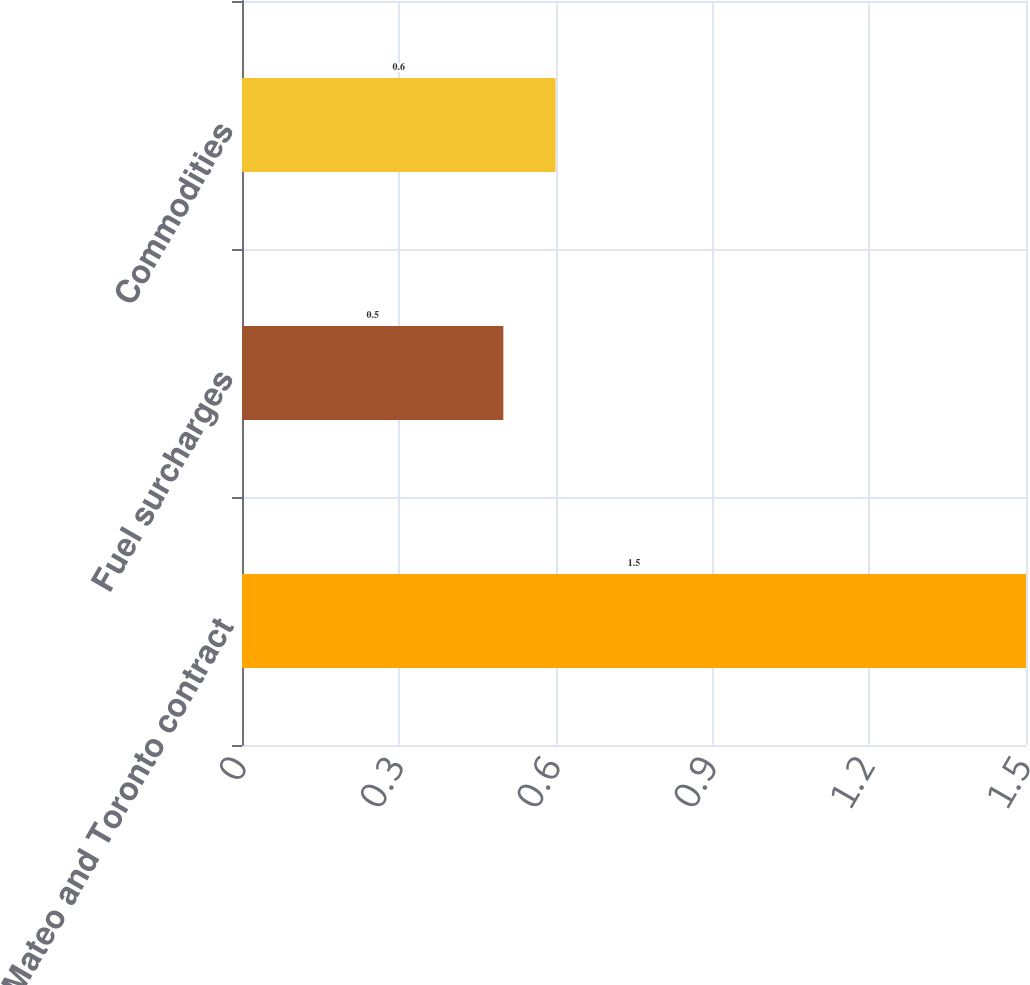<chart> <loc_0><loc_0><loc_500><loc_500><bar_chart><fcel>San Mateo and Toronto contract<fcel>Fuel surcharges<fcel>Commodities<nl><fcel>1.5<fcel>0.5<fcel>0.6<nl></chart> 